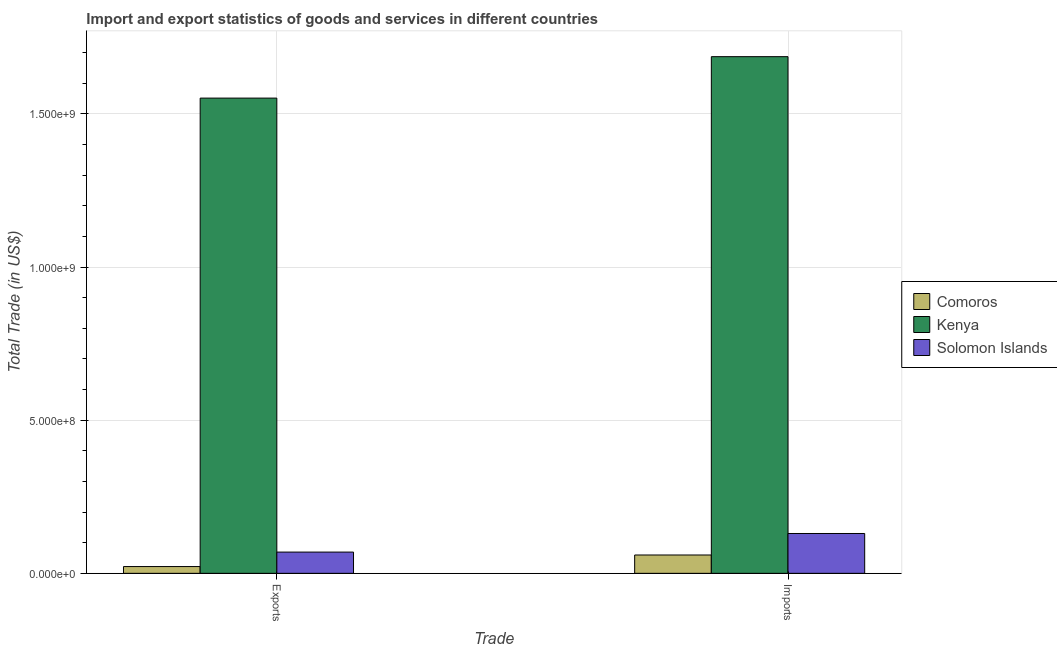How many different coloured bars are there?
Your answer should be very brief. 3. Are the number of bars on each tick of the X-axis equal?
Your answer should be compact. Yes. How many bars are there on the 1st tick from the left?
Ensure brevity in your answer.  3. What is the label of the 1st group of bars from the left?
Offer a terse response. Exports. What is the imports of goods and services in Comoros?
Offer a terse response. 5.99e+07. Across all countries, what is the maximum export of goods and services?
Ensure brevity in your answer.  1.55e+09. Across all countries, what is the minimum export of goods and services?
Offer a very short reply. 2.21e+07. In which country was the imports of goods and services maximum?
Ensure brevity in your answer.  Kenya. In which country was the imports of goods and services minimum?
Your answer should be compact. Comoros. What is the total imports of goods and services in the graph?
Provide a succinct answer. 1.88e+09. What is the difference between the imports of goods and services in Comoros and that in Kenya?
Offer a very short reply. -1.63e+09. What is the difference between the export of goods and services in Solomon Islands and the imports of goods and services in Kenya?
Provide a short and direct response. -1.62e+09. What is the average export of goods and services per country?
Keep it short and to the point. 5.48e+08. What is the difference between the export of goods and services and imports of goods and services in Solomon Islands?
Give a very brief answer. -6.07e+07. In how many countries, is the imports of goods and services greater than 700000000 US$?
Give a very brief answer. 1. What is the ratio of the export of goods and services in Kenya to that in Solomon Islands?
Your answer should be very brief. 22.36. What does the 1st bar from the left in Imports represents?
Your answer should be very brief. Comoros. What does the 1st bar from the right in Imports represents?
Ensure brevity in your answer.  Solomon Islands. How many bars are there?
Provide a succinct answer. 6. How many countries are there in the graph?
Your response must be concise. 3. Does the graph contain any zero values?
Make the answer very short. No. How many legend labels are there?
Ensure brevity in your answer.  3. How are the legend labels stacked?
Your answer should be very brief. Vertical. What is the title of the graph?
Provide a succinct answer. Import and export statistics of goods and services in different countries. Does "Angola" appear as one of the legend labels in the graph?
Offer a terse response. No. What is the label or title of the X-axis?
Provide a succinct answer. Trade. What is the label or title of the Y-axis?
Offer a very short reply. Total Trade (in US$). What is the Total Trade (in US$) in Comoros in Exports?
Offer a terse response. 2.21e+07. What is the Total Trade (in US$) in Kenya in Exports?
Give a very brief answer. 1.55e+09. What is the Total Trade (in US$) of Solomon Islands in Exports?
Offer a terse response. 6.94e+07. What is the Total Trade (in US$) of Comoros in Imports?
Keep it short and to the point. 5.99e+07. What is the Total Trade (in US$) in Kenya in Imports?
Ensure brevity in your answer.  1.69e+09. What is the Total Trade (in US$) of Solomon Islands in Imports?
Your answer should be very brief. 1.30e+08. Across all Trade, what is the maximum Total Trade (in US$) in Comoros?
Your response must be concise. 5.99e+07. Across all Trade, what is the maximum Total Trade (in US$) in Kenya?
Offer a very short reply. 1.69e+09. Across all Trade, what is the maximum Total Trade (in US$) in Solomon Islands?
Provide a succinct answer. 1.30e+08. Across all Trade, what is the minimum Total Trade (in US$) in Comoros?
Offer a terse response. 2.21e+07. Across all Trade, what is the minimum Total Trade (in US$) of Kenya?
Your answer should be compact. 1.55e+09. Across all Trade, what is the minimum Total Trade (in US$) of Solomon Islands?
Give a very brief answer. 6.94e+07. What is the total Total Trade (in US$) in Comoros in the graph?
Your response must be concise. 8.20e+07. What is the total Total Trade (in US$) in Kenya in the graph?
Provide a short and direct response. 3.24e+09. What is the total Total Trade (in US$) of Solomon Islands in the graph?
Provide a succinct answer. 1.99e+08. What is the difference between the Total Trade (in US$) of Comoros in Exports and that in Imports?
Keep it short and to the point. -3.78e+07. What is the difference between the Total Trade (in US$) of Kenya in Exports and that in Imports?
Your answer should be compact. -1.35e+08. What is the difference between the Total Trade (in US$) of Solomon Islands in Exports and that in Imports?
Provide a short and direct response. -6.07e+07. What is the difference between the Total Trade (in US$) in Comoros in Exports and the Total Trade (in US$) in Kenya in Imports?
Keep it short and to the point. -1.66e+09. What is the difference between the Total Trade (in US$) in Comoros in Exports and the Total Trade (in US$) in Solomon Islands in Imports?
Offer a very short reply. -1.08e+08. What is the difference between the Total Trade (in US$) of Kenya in Exports and the Total Trade (in US$) of Solomon Islands in Imports?
Give a very brief answer. 1.42e+09. What is the average Total Trade (in US$) of Comoros per Trade?
Your answer should be compact. 4.10e+07. What is the average Total Trade (in US$) of Kenya per Trade?
Ensure brevity in your answer.  1.62e+09. What is the average Total Trade (in US$) in Solomon Islands per Trade?
Offer a very short reply. 9.97e+07. What is the difference between the Total Trade (in US$) of Comoros and Total Trade (in US$) of Kenya in Exports?
Ensure brevity in your answer.  -1.53e+09. What is the difference between the Total Trade (in US$) of Comoros and Total Trade (in US$) of Solomon Islands in Exports?
Offer a terse response. -4.73e+07. What is the difference between the Total Trade (in US$) in Kenya and Total Trade (in US$) in Solomon Islands in Exports?
Provide a succinct answer. 1.48e+09. What is the difference between the Total Trade (in US$) in Comoros and Total Trade (in US$) in Kenya in Imports?
Ensure brevity in your answer.  -1.63e+09. What is the difference between the Total Trade (in US$) of Comoros and Total Trade (in US$) of Solomon Islands in Imports?
Provide a short and direct response. -7.02e+07. What is the difference between the Total Trade (in US$) in Kenya and Total Trade (in US$) in Solomon Islands in Imports?
Provide a short and direct response. 1.56e+09. What is the ratio of the Total Trade (in US$) in Comoros in Exports to that in Imports?
Your answer should be very brief. 0.37. What is the ratio of the Total Trade (in US$) of Kenya in Exports to that in Imports?
Ensure brevity in your answer.  0.92. What is the ratio of the Total Trade (in US$) of Solomon Islands in Exports to that in Imports?
Make the answer very short. 0.53. What is the difference between the highest and the second highest Total Trade (in US$) of Comoros?
Your answer should be very brief. 3.78e+07. What is the difference between the highest and the second highest Total Trade (in US$) of Kenya?
Provide a succinct answer. 1.35e+08. What is the difference between the highest and the second highest Total Trade (in US$) in Solomon Islands?
Give a very brief answer. 6.07e+07. What is the difference between the highest and the lowest Total Trade (in US$) in Comoros?
Keep it short and to the point. 3.78e+07. What is the difference between the highest and the lowest Total Trade (in US$) in Kenya?
Provide a succinct answer. 1.35e+08. What is the difference between the highest and the lowest Total Trade (in US$) of Solomon Islands?
Make the answer very short. 6.07e+07. 